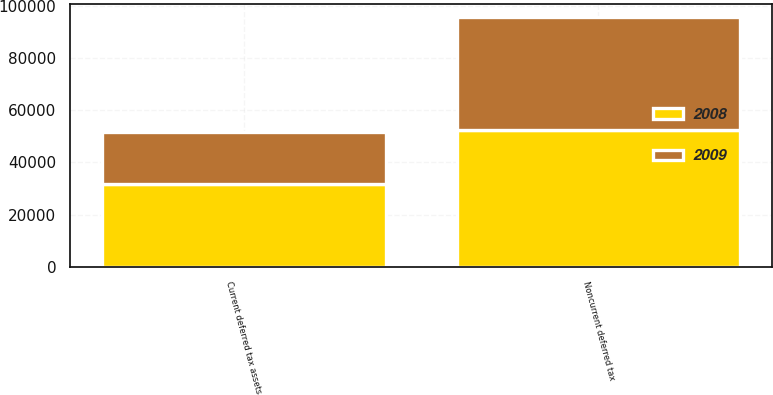Convert chart to OTSL. <chart><loc_0><loc_0><loc_500><loc_500><stacked_bar_chart><ecel><fcel>Current deferred tax assets<fcel>Noncurrent deferred tax<nl><fcel>2008<fcel>31847<fcel>52209<nl><fcel>2009<fcel>19644<fcel>43518<nl></chart> 